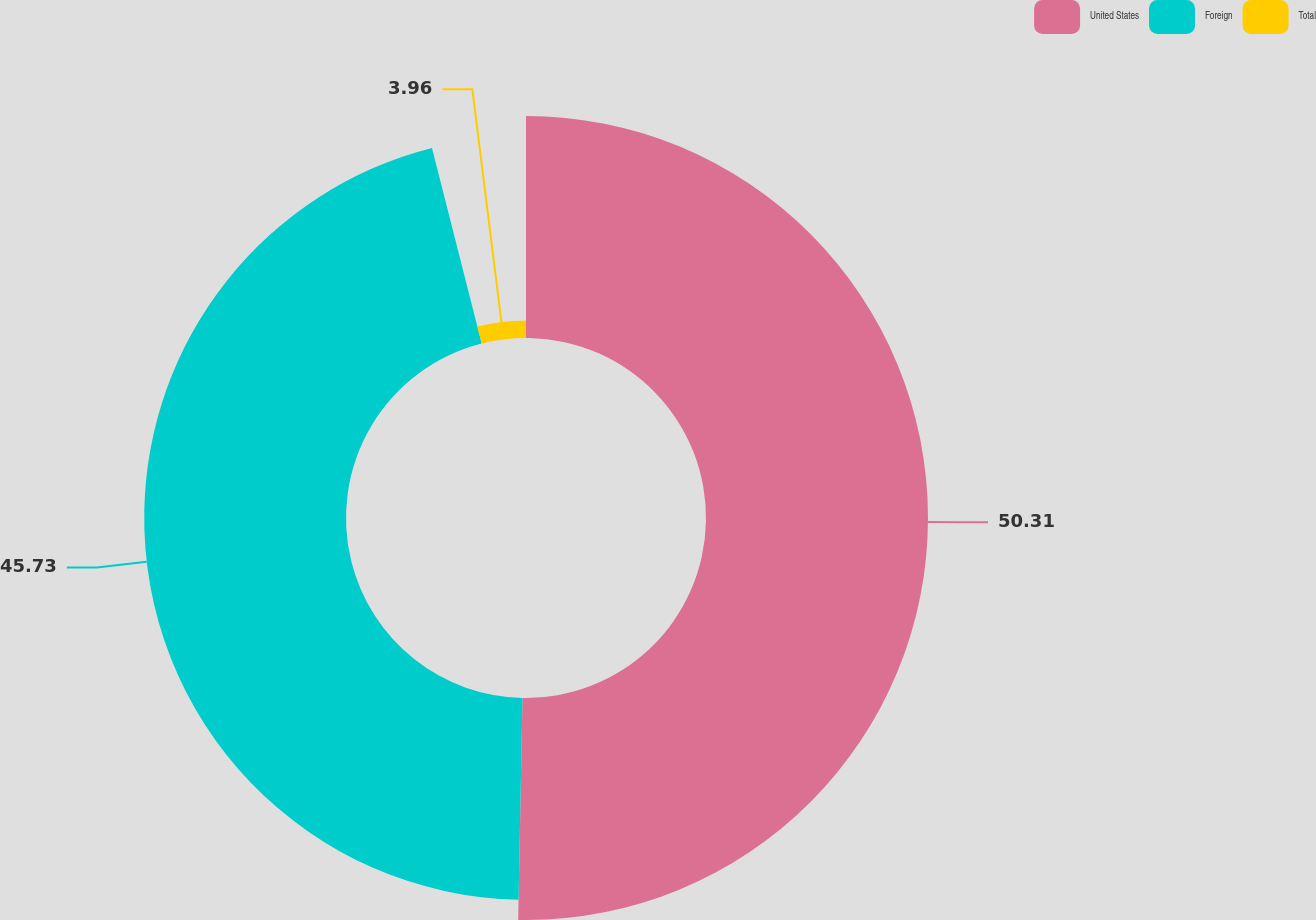<chart> <loc_0><loc_0><loc_500><loc_500><pie_chart><fcel>United States<fcel>Foreign<fcel>Total<nl><fcel>50.31%<fcel>45.73%<fcel>3.96%<nl></chart> 